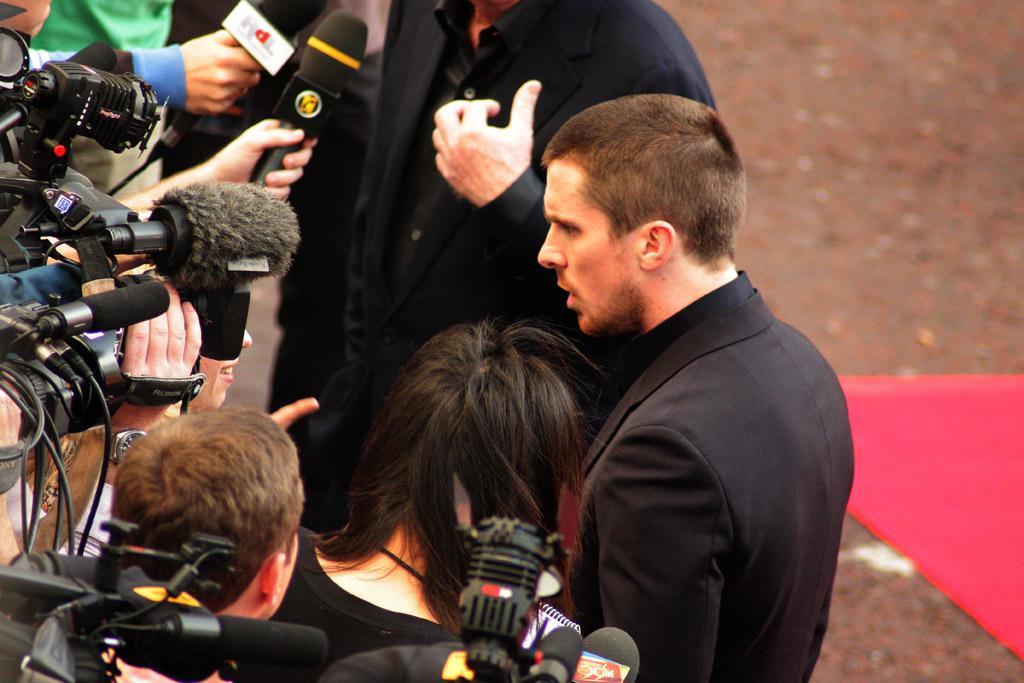How would you summarize this image in a sentence or two? In this picture we can see four persons and in front of them there are persons holding mic with their hands and pointing at these persons and in the background we can see some cloth, land. 